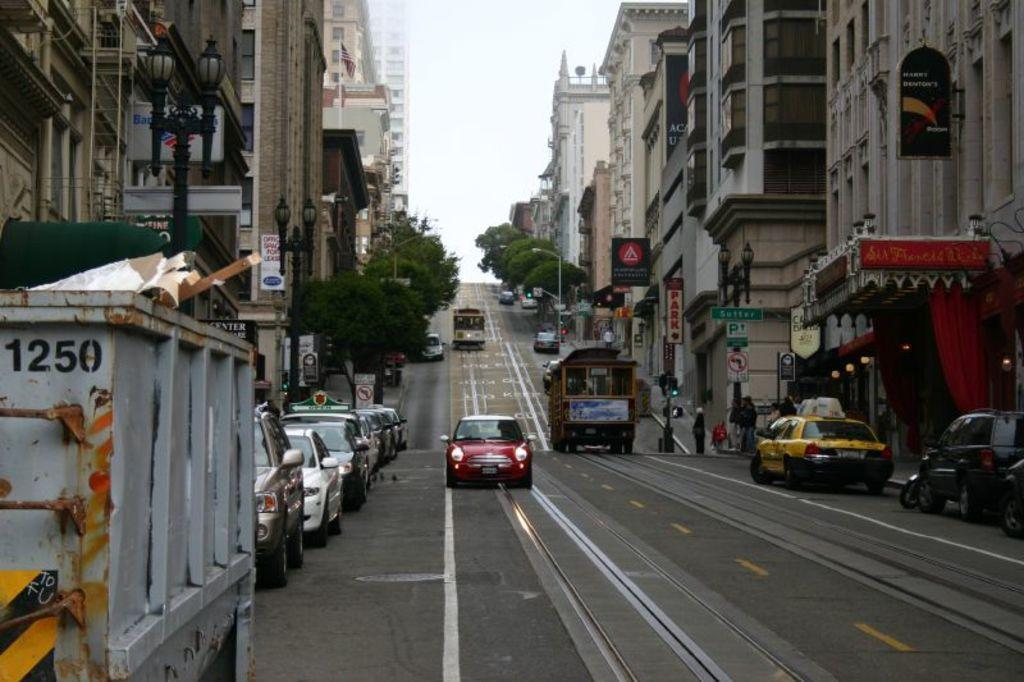<image>
Write a terse but informative summary of the picture. a truck that has the numbers 1250 on it 